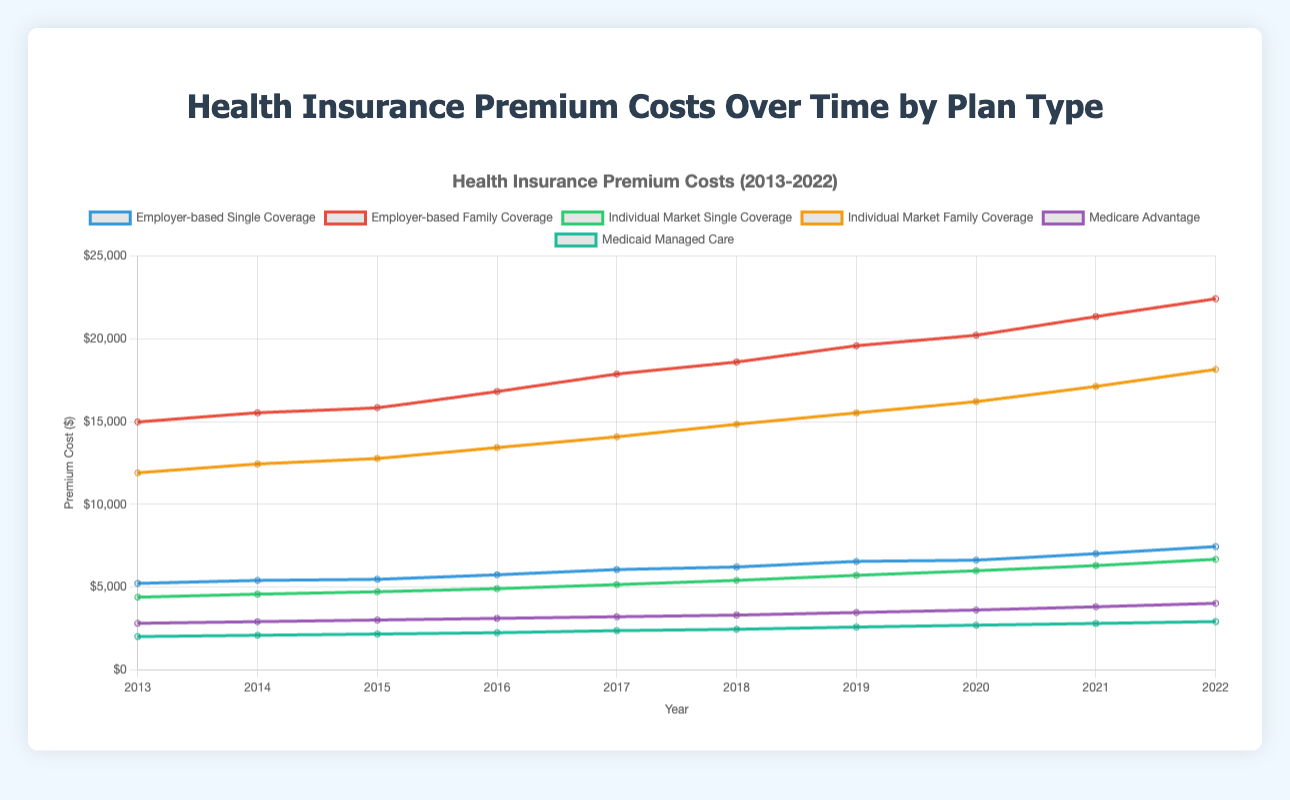What type of plan had the highest premium cost in 2022? Look at the values for 2022 on the y-axis for all plans and identify the plan with the highest value. The highest value is 22420 under "Employer-based Family Coverage".
Answer: Employer-based Family Coverage How did the premium cost for Medicaid Managed Care change from 2013 to 2022? Note the values for Medicaid Managed Care in 2013 and 2022 which are 2003 and 2908, respectively. Calculate the difference: 2908 - 2003.
Answer: Increased by 905 Which plan had the smallest increase in premium cost from 2013 to 2022? Calculate the difference between 2022 and 2013 values for all plans. The plan with the smallest increase is Medicaid Managed Care: 2908 - 2003 = 905.
Answer: Medicaid Managed Care Compare the premium costs for Employer-based Single Coverage and Individual Market Single Coverage in 2022. Which was higher? Compare the 2022 values for both plans: Employer-based Single Coverage (7440) vs. Individual Market Single Coverage (6672). Identify the higher value.
Answer: Employer-based Single Coverage What was the average premium cost for Medicare Advantage over the period from 2013 to 2022? Sum the 10 yearly values for Medicare Advantage: 2804, 2903, 3003, 3102, 3201, 3300, 3456, 3608, 3803, 4012 and divide by the number of years (10): (2804+2903+3003+3102+3201+3300+3456+3608+3803+4012)/10.
Answer: 33.192 In which year did Individual Market Family Coverage first exceed $15,000? Locate the first year when the premium cost for Individual Market Family Coverage is above $15,000. In 2018, the cost is 14834, and in 2019, it is 15522.
Answer: 2019 How much higher was the premium cost for Employer-based Family Coverage than for Individual Market Family Coverage in 2022? Subtract the 2022 value for Individual Market Family Coverage (18150) from the 2022 value for Employer-based Family Coverage (22420): 22420 - 18150.
Answer: 4270 Which plan had the most significant increase in premium cost between 2019 and 2020? Calculate the difference between 2020 and 2019 values for all plans and identify the highest difference. Employer-based Family Coverage shows the largest increase: 20221 - 19578 = 643.
Answer: Employer-based Family Coverage Rank the plans based on their last recorded premium cost in 2022 from highest to lowest. Arrange the 2022 values in descending order: Employer-based Family Coverage (22420), Individual Market Family Coverage (18150), Employer-based Single Coverage (7440), Individual Market Single Coverage (6672), Medicare Advantage (4012), Medicaid Managed Care (2908).
Answer: Employer-based Family Coverage, Individual Market Family Coverage, Employer-based Single Coverage, Individual Market Single Coverage, Medicare Advantage, Medicaid Managed Care 